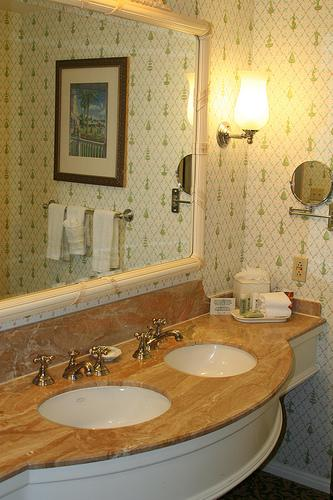Provide a description of the sink area and its accessories in the bathroom. White sinks are set on a brown countertop, accompanied by a silver faucet, soap dish, tissue holder, toiletries, and white towels. Write a brief sentence about the towel arrangement in the bathroom image. White towels are neatly folded and placed on a silver towel bar and a tray in the bathroom. In one sentence, describe the types of mirrors present in the bathroom. The bathroom has a large rectangular mirror above the vanity and a small round vanity mirror hanging on the wall. Write a concise overview of what's included in this bathroom image. The image shows a bathroom with a vanity, two mirrors, a towel bar, white towels, a framed picture, and green tree wallpaper. Briefly describe the bathroom accessories visible in the image. The bathroom has a silver faucet, white ceramic sink, soap dish, tissue holder, white towels on a tray, toiletries on a tray, and an outlet. Enumerate the primary elements visible in the image. Rectangular mirror, round vanity mirror, white sinks, silver faucet, silver towel bar, white towels, brown framed picture, wallpaper with green tree. Compose a sentence about the type of wallpapers and the counter present in the image. The image displays a bathroom with green tree wallpaper and a brown marble countertop. Mention the primary colors visible in this bathroom image. White, silver, beige, green, and brown are the main colors visible in this bathroom image. Mention the type of image on the wall and any reflected objects in the mirrors. A painting in a brown frame is hanging on the wall, and the mirrors reflect the painting and the bathroom sink. Mention the main furniture and decorative elements of this bathroom. There is a rectangular mirror, round vanity mirror, white sinks, silver faucet, silver towel bar, white towels, picture with brown frame, and green tree wallpaper. 